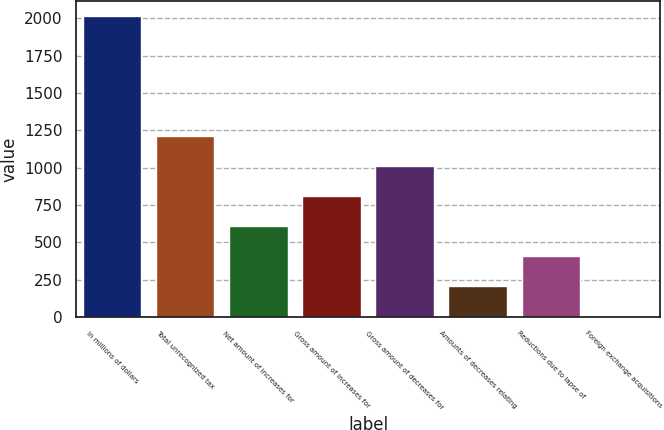Convert chart. <chart><loc_0><loc_0><loc_500><loc_500><bar_chart><fcel>In millions of dollars<fcel>Total unrecognized tax<fcel>Net amount of increases for<fcel>Gross amount of increases for<fcel>Gross amount of decreases for<fcel>Amounts of decreases relating<fcel>Reductions due to lapse of<fcel>Foreign exchange acquisitions<nl><fcel>2014<fcel>1210.8<fcel>608.4<fcel>809.2<fcel>1010<fcel>206.8<fcel>407.6<fcel>6<nl></chart> 